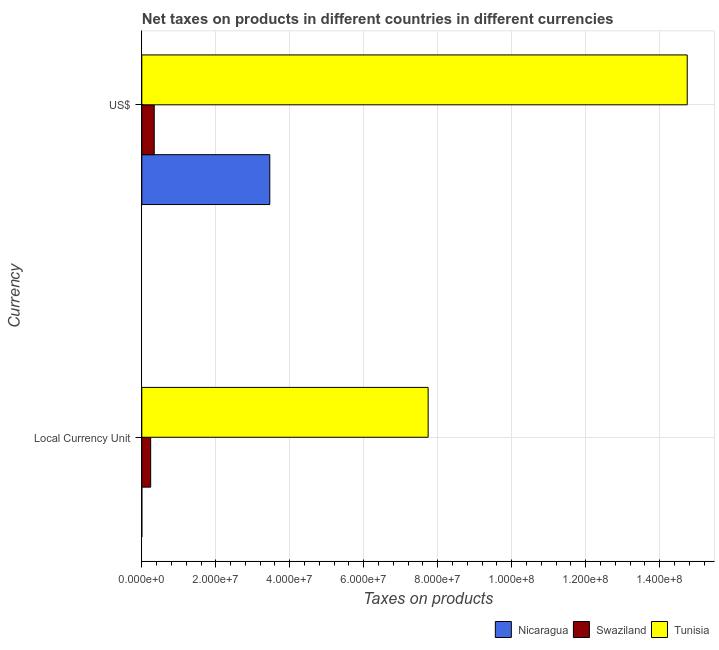How many different coloured bars are there?
Make the answer very short. 3. How many groups of bars are there?
Provide a succinct answer. 2. Are the number of bars per tick equal to the number of legend labels?
Offer a terse response. Yes. Are the number of bars on each tick of the Y-axis equal?
Keep it short and to the point. Yes. How many bars are there on the 2nd tick from the top?
Provide a short and direct response. 3. How many bars are there on the 1st tick from the bottom?
Your answer should be compact. 3. What is the label of the 2nd group of bars from the top?
Ensure brevity in your answer.  Local Currency Unit. What is the net taxes in constant 2005 us$ in Tunisia?
Make the answer very short. 7.74e+07. Across all countries, what is the maximum net taxes in us$?
Keep it short and to the point. 1.47e+08. Across all countries, what is the minimum net taxes in us$?
Offer a very short reply. 3.36e+06. In which country was the net taxes in constant 2005 us$ maximum?
Offer a very short reply. Tunisia. In which country was the net taxes in us$ minimum?
Your answer should be very brief. Swaziland. What is the total net taxes in constant 2005 us$ in the graph?
Offer a very short reply. 7.98e+07. What is the difference between the net taxes in us$ in Nicaragua and that in Swaziland?
Provide a succinct answer. 3.12e+07. What is the difference between the net taxes in constant 2005 us$ in Tunisia and the net taxes in us$ in Swaziland?
Your answer should be very brief. 7.40e+07. What is the average net taxes in constant 2005 us$ per country?
Give a very brief answer. 2.66e+07. What is the difference between the net taxes in constant 2005 us$ and net taxes in us$ in Nicaragua?
Offer a terse response. -3.46e+07. What is the ratio of the net taxes in us$ in Nicaragua to that in Tunisia?
Your answer should be compact. 0.23. Is the net taxes in constant 2005 us$ in Swaziland less than that in Tunisia?
Ensure brevity in your answer.  Yes. In how many countries, is the net taxes in constant 2005 us$ greater than the average net taxes in constant 2005 us$ taken over all countries?
Provide a short and direct response. 1. What does the 2nd bar from the top in US$ represents?
Offer a very short reply. Swaziland. What does the 1st bar from the bottom in Local Currency Unit represents?
Make the answer very short. Nicaragua. How many bars are there?
Make the answer very short. 6. Are all the bars in the graph horizontal?
Provide a succinct answer. Yes. What is the difference between two consecutive major ticks on the X-axis?
Ensure brevity in your answer.  2.00e+07. Does the graph contain any zero values?
Give a very brief answer. No. How many legend labels are there?
Make the answer very short. 3. How are the legend labels stacked?
Offer a terse response. Horizontal. What is the title of the graph?
Offer a terse response. Net taxes on products in different countries in different currencies. What is the label or title of the X-axis?
Offer a terse response. Taxes on products. What is the label or title of the Y-axis?
Make the answer very short. Currency. What is the Taxes on products of Nicaragua in Local Currency Unit?
Provide a succinct answer. 0.05. What is the Taxes on products of Swaziland in Local Currency Unit?
Keep it short and to the point. 2.40e+06. What is the Taxes on products in Tunisia in Local Currency Unit?
Make the answer very short. 7.74e+07. What is the Taxes on products of Nicaragua in US$?
Make the answer very short. 3.46e+07. What is the Taxes on products of Swaziland in US$?
Keep it short and to the point. 3.36e+06. What is the Taxes on products in Tunisia in US$?
Ensure brevity in your answer.  1.47e+08. Across all Currency, what is the maximum Taxes on products in Nicaragua?
Ensure brevity in your answer.  3.46e+07. Across all Currency, what is the maximum Taxes on products in Swaziland?
Keep it short and to the point. 3.36e+06. Across all Currency, what is the maximum Taxes on products in Tunisia?
Your response must be concise. 1.47e+08. Across all Currency, what is the minimum Taxes on products of Nicaragua?
Give a very brief answer. 0.05. Across all Currency, what is the minimum Taxes on products in Swaziland?
Ensure brevity in your answer.  2.40e+06. Across all Currency, what is the minimum Taxes on products in Tunisia?
Offer a terse response. 7.74e+07. What is the total Taxes on products in Nicaragua in the graph?
Your response must be concise. 3.46e+07. What is the total Taxes on products in Swaziland in the graph?
Your answer should be very brief. 5.76e+06. What is the total Taxes on products of Tunisia in the graph?
Offer a terse response. 2.25e+08. What is the difference between the Taxes on products in Nicaragua in Local Currency Unit and that in US$?
Ensure brevity in your answer.  -3.46e+07. What is the difference between the Taxes on products in Swaziland in Local Currency Unit and that in US$?
Make the answer very short. -9.60e+05. What is the difference between the Taxes on products in Tunisia in Local Currency Unit and that in US$?
Provide a short and direct response. -7.00e+07. What is the difference between the Taxes on products in Nicaragua in Local Currency Unit and the Taxes on products in Swaziland in US$?
Provide a succinct answer. -3.36e+06. What is the difference between the Taxes on products in Nicaragua in Local Currency Unit and the Taxes on products in Tunisia in US$?
Your answer should be compact. -1.47e+08. What is the difference between the Taxes on products in Swaziland in Local Currency Unit and the Taxes on products in Tunisia in US$?
Provide a short and direct response. -1.45e+08. What is the average Taxes on products in Nicaragua per Currency?
Provide a succinct answer. 1.73e+07. What is the average Taxes on products of Swaziland per Currency?
Make the answer very short. 2.88e+06. What is the average Taxes on products in Tunisia per Currency?
Your response must be concise. 1.12e+08. What is the difference between the Taxes on products in Nicaragua and Taxes on products in Swaziland in Local Currency Unit?
Your answer should be compact. -2.40e+06. What is the difference between the Taxes on products in Nicaragua and Taxes on products in Tunisia in Local Currency Unit?
Your answer should be very brief. -7.74e+07. What is the difference between the Taxes on products of Swaziland and Taxes on products of Tunisia in Local Currency Unit?
Your answer should be very brief. -7.50e+07. What is the difference between the Taxes on products in Nicaragua and Taxes on products in Swaziland in US$?
Keep it short and to the point. 3.12e+07. What is the difference between the Taxes on products in Nicaragua and Taxes on products in Tunisia in US$?
Your response must be concise. -1.13e+08. What is the difference between the Taxes on products of Swaziland and Taxes on products of Tunisia in US$?
Your response must be concise. -1.44e+08. What is the ratio of the Taxes on products of Nicaragua in Local Currency Unit to that in US$?
Provide a succinct answer. 0. What is the ratio of the Taxes on products of Swaziland in Local Currency Unit to that in US$?
Your answer should be compact. 0.71. What is the ratio of the Taxes on products of Tunisia in Local Currency Unit to that in US$?
Your answer should be very brief. 0.53. What is the difference between the highest and the second highest Taxes on products of Nicaragua?
Your answer should be very brief. 3.46e+07. What is the difference between the highest and the second highest Taxes on products in Swaziland?
Provide a succinct answer. 9.60e+05. What is the difference between the highest and the second highest Taxes on products in Tunisia?
Provide a succinct answer. 7.00e+07. What is the difference between the highest and the lowest Taxes on products in Nicaragua?
Offer a very short reply. 3.46e+07. What is the difference between the highest and the lowest Taxes on products in Swaziland?
Provide a succinct answer. 9.60e+05. What is the difference between the highest and the lowest Taxes on products in Tunisia?
Give a very brief answer. 7.00e+07. 